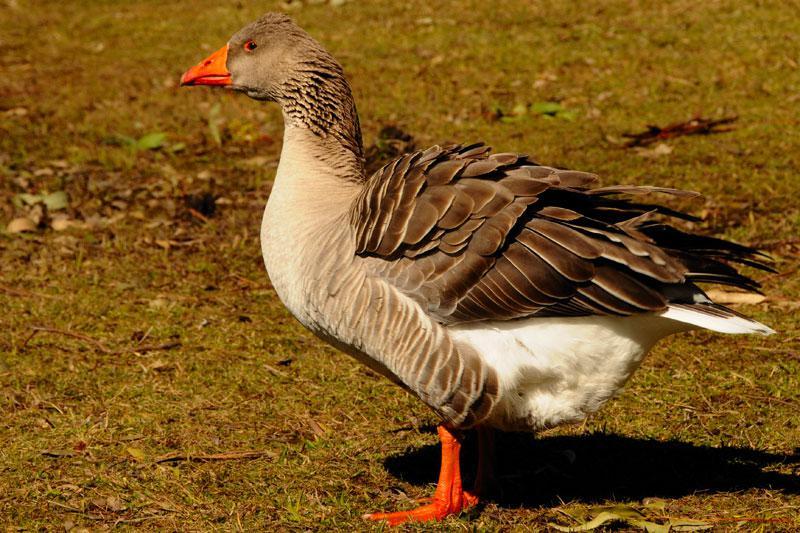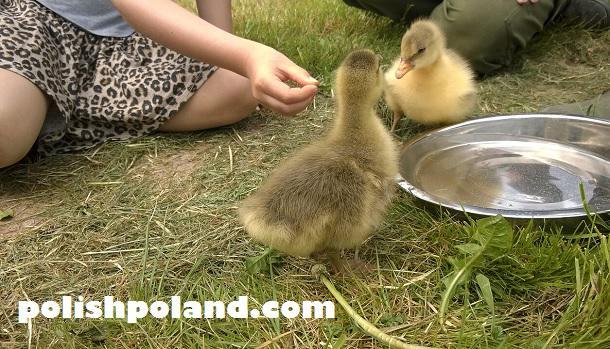The first image is the image on the left, the second image is the image on the right. Assess this claim about the two images: "No image contains fewer than four white fowl.". Correct or not? Answer yes or no. No. 